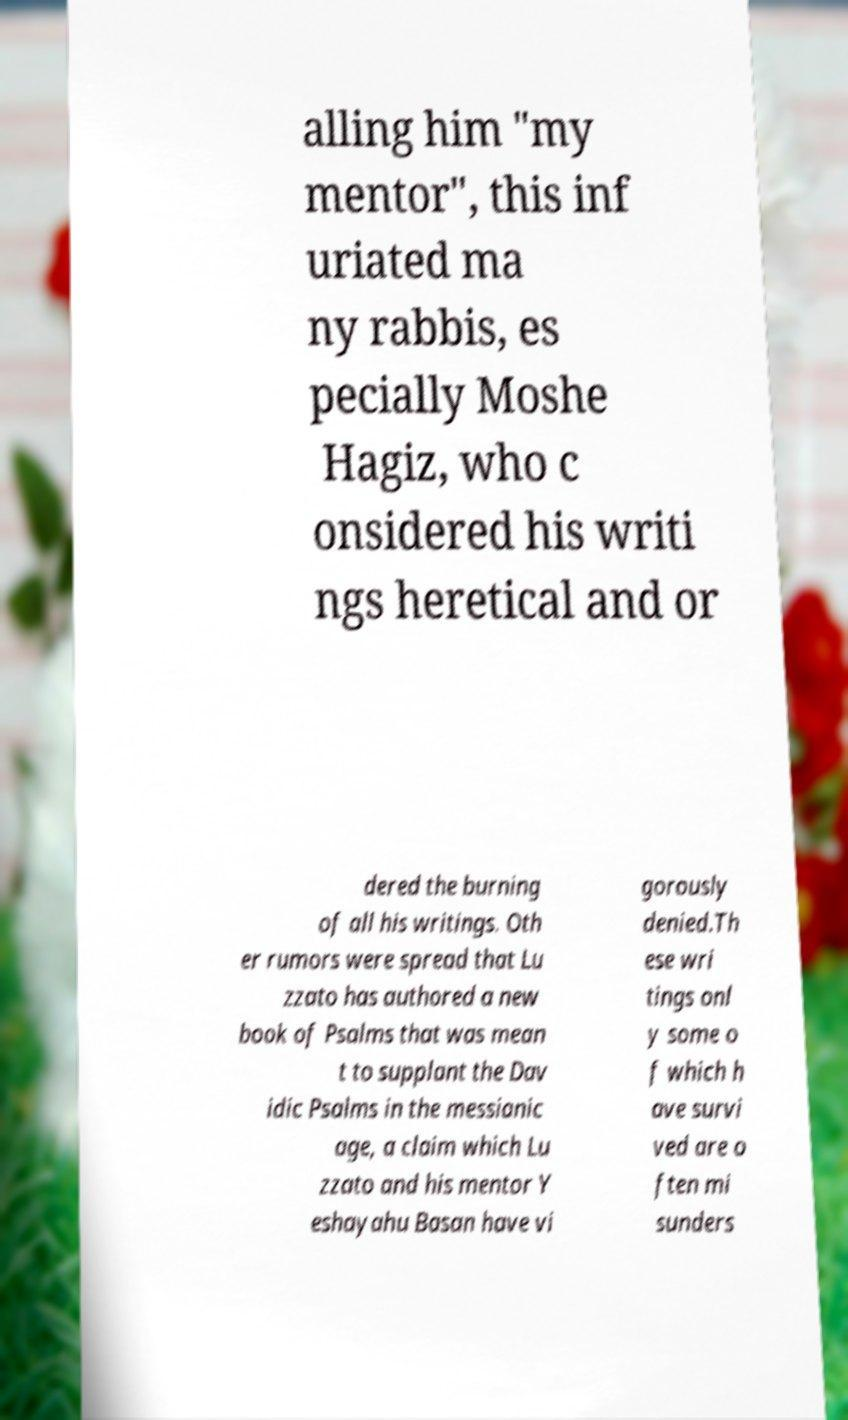What messages or text are displayed in this image? I need them in a readable, typed format. alling him "my mentor", this inf uriated ma ny rabbis, es pecially Moshe Hagiz, who c onsidered his writi ngs heretical and or dered the burning of all his writings. Oth er rumors were spread that Lu zzato has authored a new book of Psalms that was mean t to supplant the Dav idic Psalms in the messianic age, a claim which Lu zzato and his mentor Y eshayahu Basan have vi gorously denied.Th ese wri tings onl y some o f which h ave survi ved are o ften mi sunders 